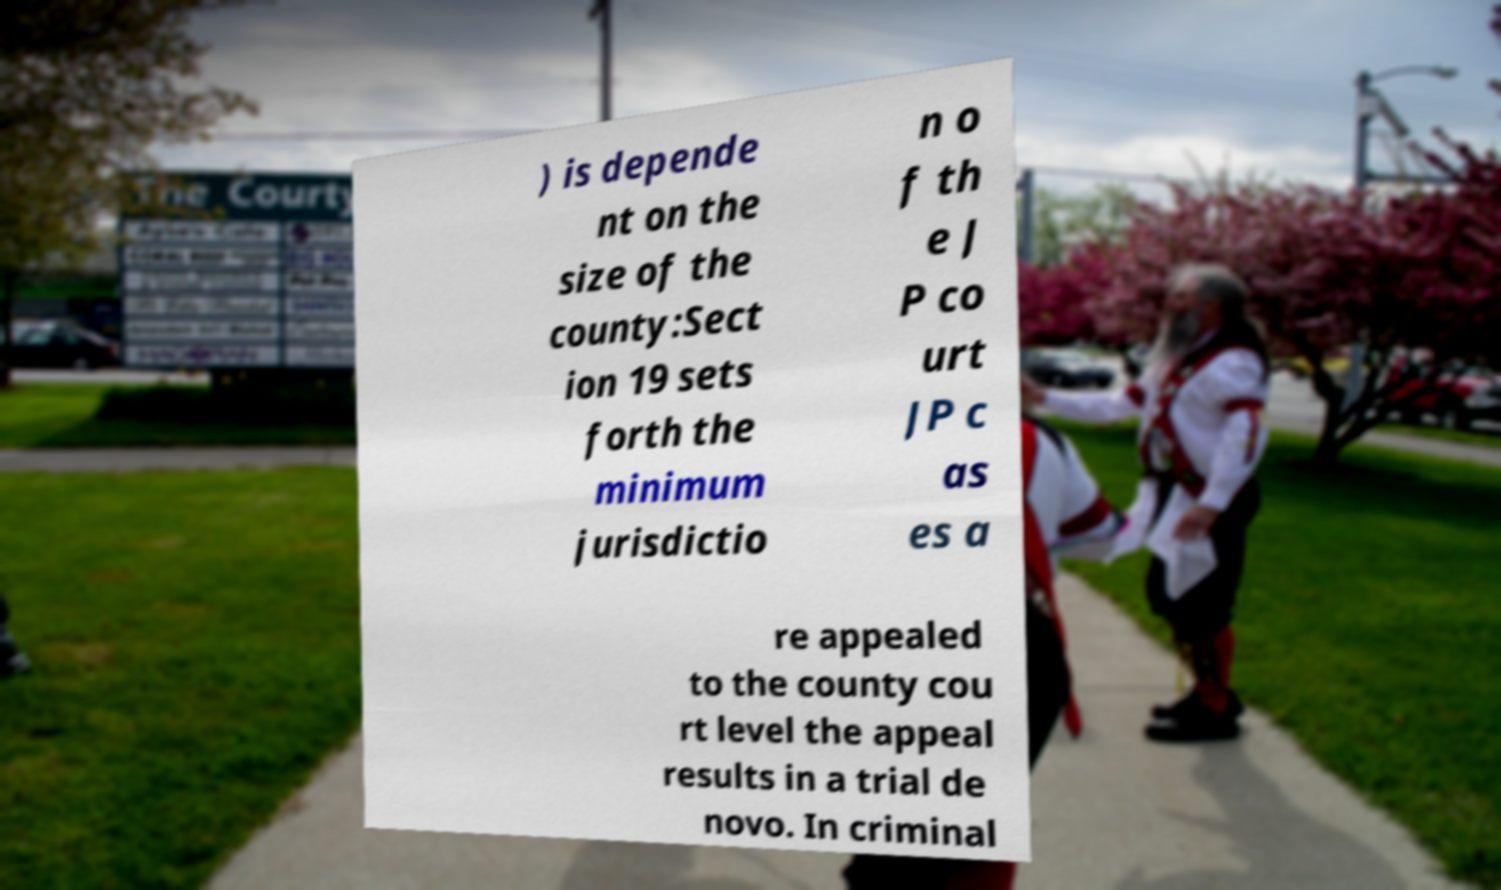I need the written content from this picture converted into text. Can you do that? ) is depende nt on the size of the county:Sect ion 19 sets forth the minimum jurisdictio n o f th e J P co urt JP c as es a re appealed to the county cou rt level the appeal results in a trial de novo. In criminal 